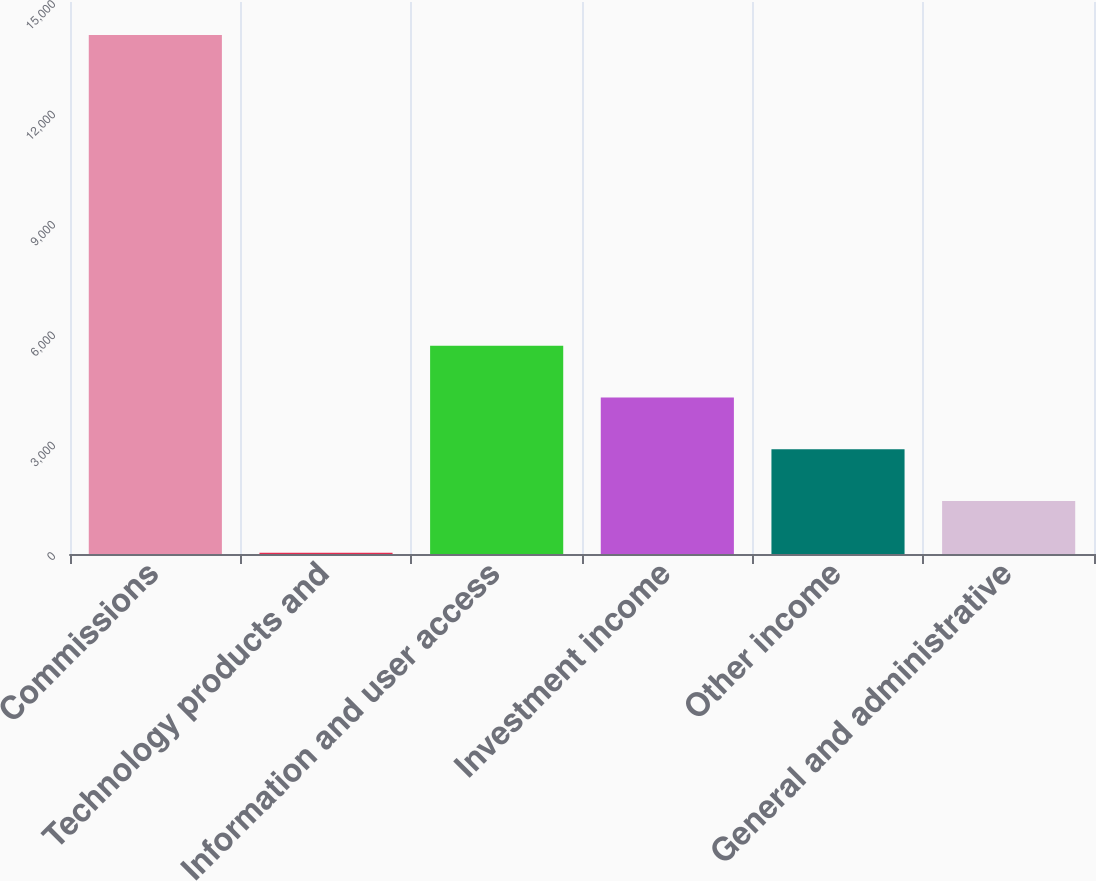<chart> <loc_0><loc_0><loc_500><loc_500><bar_chart><fcel>Commissions<fcel>Technology products and<fcel>Information and user access<fcel>Investment income<fcel>Other income<fcel>General and administrative<nl><fcel>14103<fcel>35<fcel>5662.2<fcel>4255.4<fcel>2848.6<fcel>1441.8<nl></chart> 